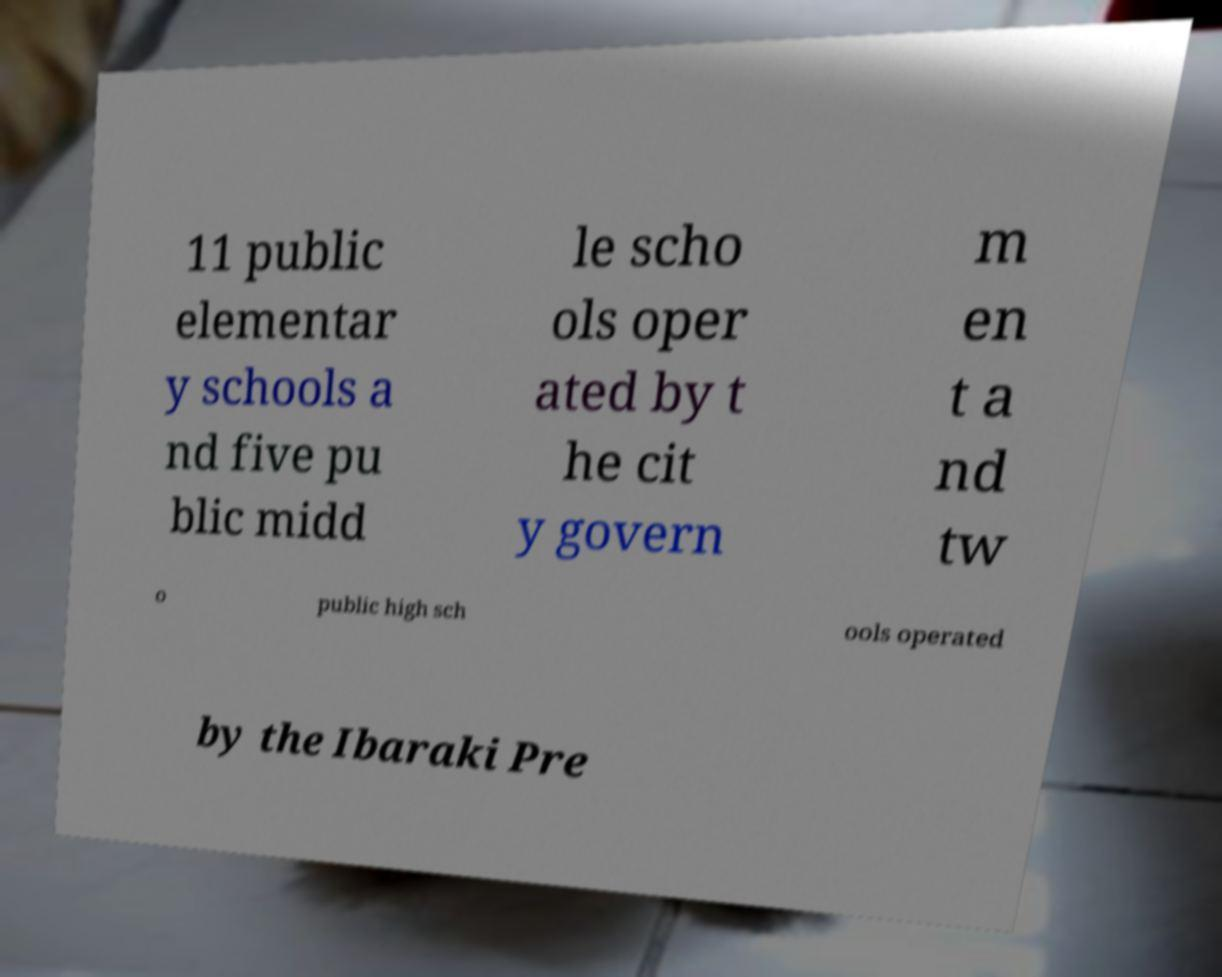Could you extract and type out the text from this image? 11 public elementar y schools a nd five pu blic midd le scho ols oper ated by t he cit y govern m en t a nd tw o public high sch ools operated by the Ibaraki Pre 